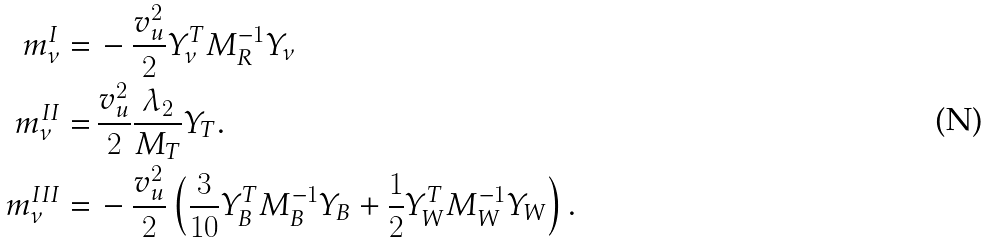<formula> <loc_0><loc_0><loc_500><loc_500>m ^ { I } _ { \nu } = & \, - \frac { v ^ { 2 } _ { u } } { 2 } Y ^ { T } _ { \nu } M ^ { - 1 } _ { R } Y _ { \nu } \\ m ^ { I I } _ { \nu } = & \, \frac { v _ { u } ^ { 2 } } { 2 } \frac { \lambda _ { 2 } } { M _ { T } } Y _ { T } . \\ m ^ { I I I } _ { \nu } = & \, - \frac { v ^ { 2 } _ { u } } { 2 } \left ( \frac { 3 } { 1 0 } Y ^ { T } _ { B } M ^ { - 1 } _ { B } Y _ { B } + \frac { 1 } { 2 } Y ^ { T } _ { W } M ^ { - 1 } _ { W } Y _ { W } \right ) .</formula> 